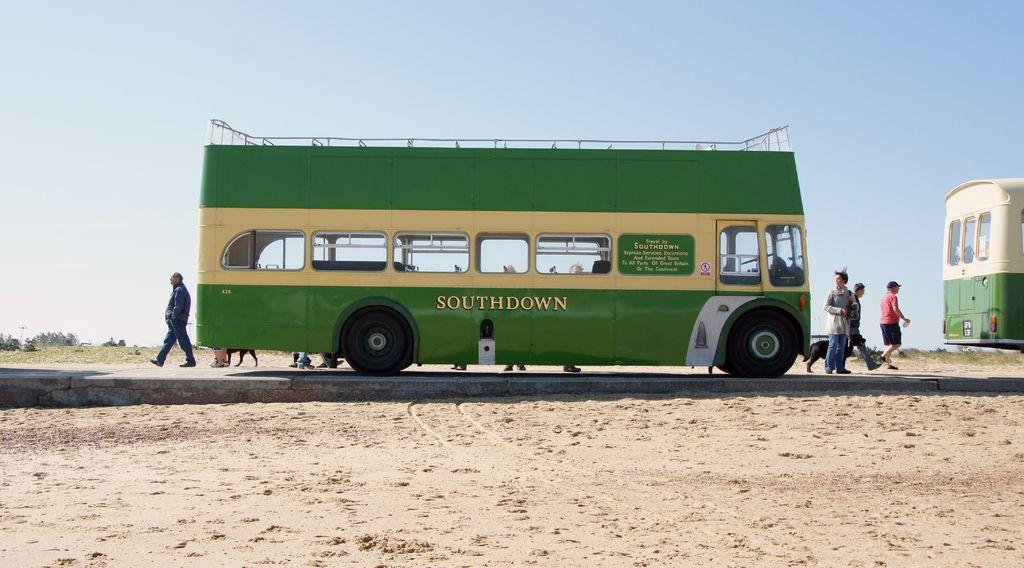How would you summarize this image in a sentence or two? In this image there are two buses parked on the road and there are a few people walking on the road surface. 